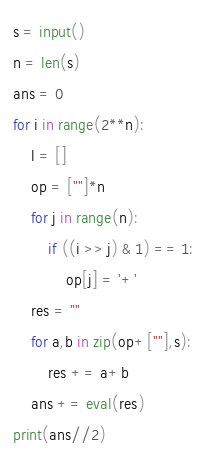<code> <loc_0><loc_0><loc_500><loc_500><_Python_>s = input()
n = len(s)
ans = 0
for i in range(2**n):
	l = []
	op = [""]*n
	for j in range(n):
		if ((i >> j) & 1) == 1:
			op[j] = '+'
	res = ""
	for a,b in zip(op+[""],s):
		res += a+b
	ans += eval(res)
print(ans//2)</code> 